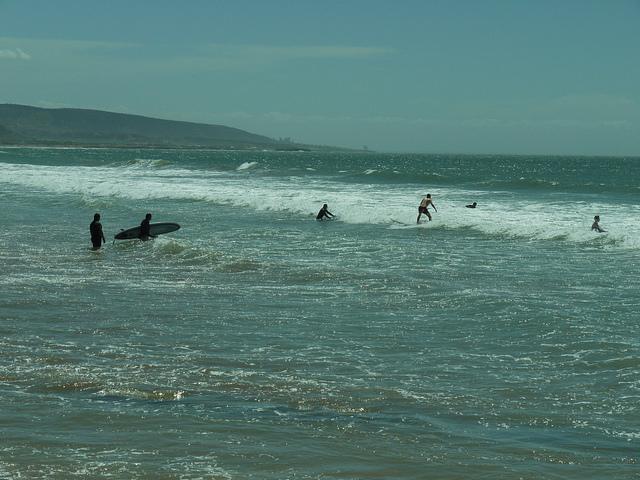How many surfers are there?
Give a very brief answer. 6. 